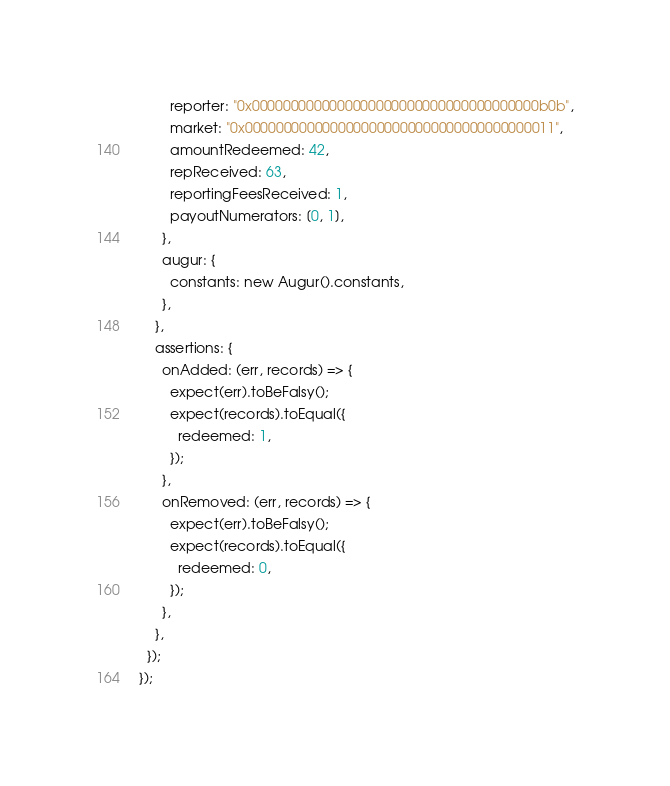Convert code to text. <code><loc_0><loc_0><loc_500><loc_500><_JavaScript_>        reporter: "0x0000000000000000000000000000000000000b0b",
        market: "0x0000000000000000000000000000000000000011",
        amountRedeemed: 42,
        repReceived: 63,
        reportingFeesReceived: 1,
        payoutNumerators: [0, 1],
      },
      augur: {
        constants: new Augur().constants,
      },
    },
    assertions: {
      onAdded: (err, records) => {
        expect(err).toBeFalsy();
        expect(records).toEqual({
          redeemed: 1,
        });
      },
      onRemoved: (err, records) => {
        expect(err).toBeFalsy();
        expect(records).toEqual({
          redeemed: 0,
        });
      },
    },
  });
});
</code> 